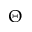<formula> <loc_0><loc_0><loc_500><loc_500>\Theta</formula> 